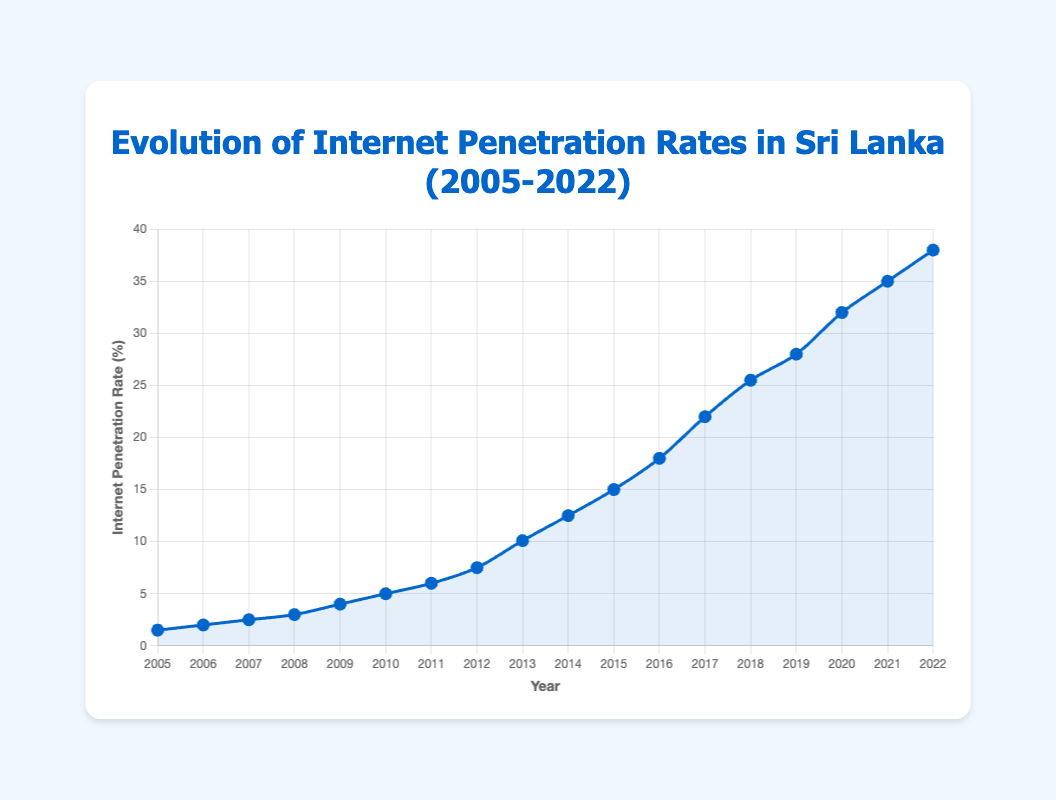What is the internet penetration rate in 2011? Locate the year 2011 on the x-axis and find the corresponding value on the y-axis. The internet penetration rate for 2011 is 6.0%.
Answer: 6.0% During which year did Sri Lanka see the largest increase in internet penetration rate from the previous year? By examining the differences between consecutive years, the largest increase is observed from 2012 to 2013, where the rate increased by 2.6% (10.1% - 7.5%).
Answer: 2013 What was the average internet penetration rate from 2005 to 2010? To compute the average, sum the rates from 2005 to 2010 (1.5 + 2.0 + 2.5 + 3.0 + 4.0 + 5.0 = 18.0) and divide by 6, resulting in 3.0%.
Answer: 3.0% Which year had the higher internet penetration rate, 2017 or 2019? By comparing the values on the y-axis for 2017 (22.0%) and 2019 (28.0%), 2019 had the higher rate.
Answer: 2019 How many years did it take for the internet penetration rate to increase from less than 10% to over 20%? Identify the years where the rates were less than 10% (2005-2012) and over 20% (2017-2022). From 2012 to 2017 was 5 years.
Answer: 5 years What is the total increase in internet penetration rate from 2005 to 2022? Find the difference between the rates in 2022 (38.0%) and 2005 (1.5%), which is 38.0 - 1.5 = 36.5%.
Answer: 36.5% Which year had the smallest year-over-year increase in internet penetration rate? By evaluating each year's difference, the smallest increase is from 2006 to 2007 (2.5% - 2.0% = 0.5%).
Answer: 2007 What was the internet penetration rate in the midpoint year of 2013? Locate 2013 on the x-axis to find a rate of 10.1%.
Answer: 10.1% Compare the internet penetration rates of 2010 and 2015. Which year has the greater rate and by how much? The rate in 2010 is 5.0% and in 2015 is 15.0%. The difference is 15.0% - 5.0% = 10.0%. 2015 is greater by 10.0%.
Answer: 2015, 10.0% How did the rate change from 2020 to 2022? The rate in 2020 was 32.0% and in 2022 was 38.0%. The change was 38.0% - 32.0% = 6.0%.
Answer: 6.0% 